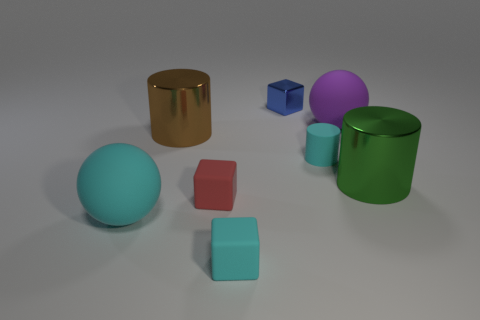There is a large thing that is on the right side of the cyan cube and to the left of the big green cylinder; what material is it made of?
Make the answer very short. Rubber. What is the material of the cyan object that is the same size as the green shiny cylinder?
Offer a very short reply. Rubber. Is the number of large cyan spheres less than the number of metallic objects?
Provide a short and direct response. Yes. What color is the other big rubber thing that is the same shape as the large cyan rubber object?
Your answer should be very brief. Purple. There is a rubber ball that is in front of the big cylinder that is right of the tiny red matte object; are there any green cylinders on the right side of it?
Provide a short and direct response. Yes. Is the large cyan rubber object the same shape as the big brown metal thing?
Offer a terse response. No. Are there fewer large cyan things that are on the right side of the tiny cyan matte block than large cyan shiny cylinders?
Your answer should be very brief. No. There is a large matte ball behind the big object that is right of the large ball that is behind the large cyan rubber ball; what is its color?
Offer a terse response. Purple. How many matte objects are tiny balls or tiny cubes?
Give a very brief answer. 2. Does the cyan matte block have the same size as the red cube?
Make the answer very short. Yes. 